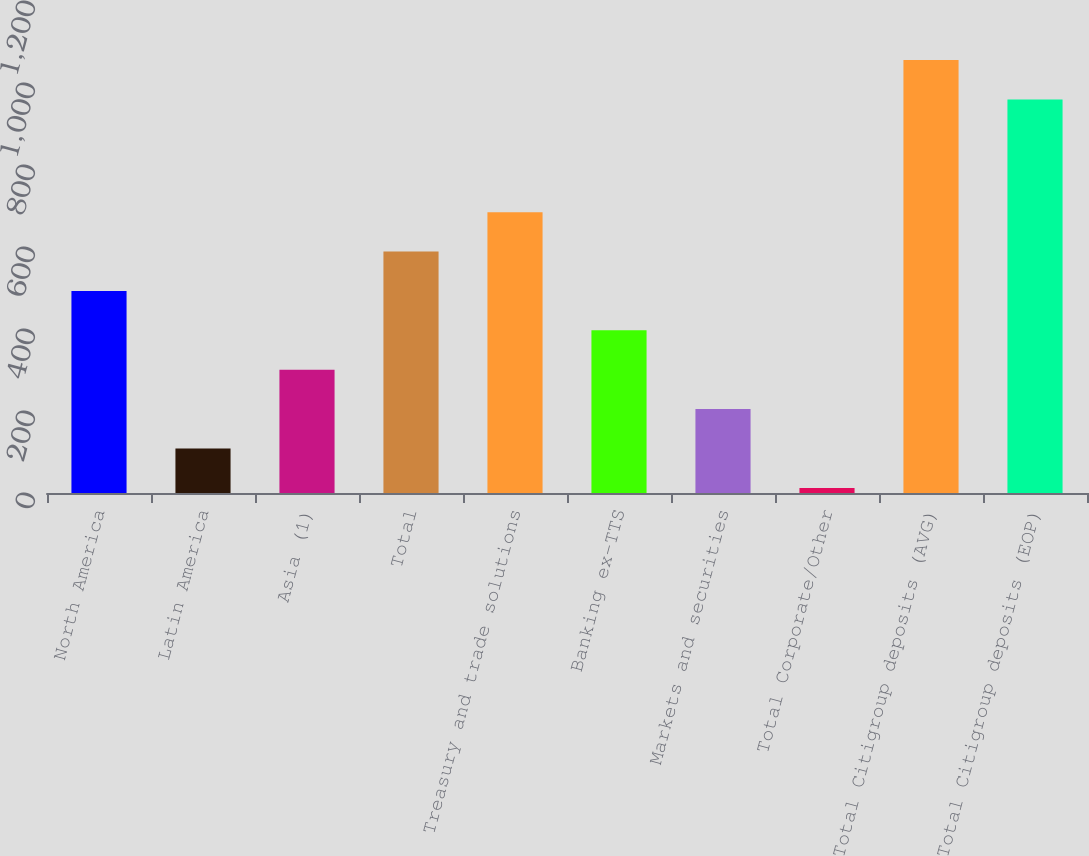<chart> <loc_0><loc_0><loc_500><loc_500><bar_chart><fcel>North America<fcel>Latin America<fcel>Asia (1)<fcel>Total<fcel>Treasury and trade solutions<fcel>Banking ex-TTS<fcel>Markets and securities<fcel>Total Corporate/Other<fcel>Total Citigroup deposits (AVG)<fcel>Total Citigroup deposits (EOP)<nl><fcel>492.85<fcel>108.49<fcel>300.67<fcel>588.94<fcel>685.03<fcel>396.76<fcel>204.58<fcel>12.4<fcel>1055.89<fcel>959.8<nl></chart> 